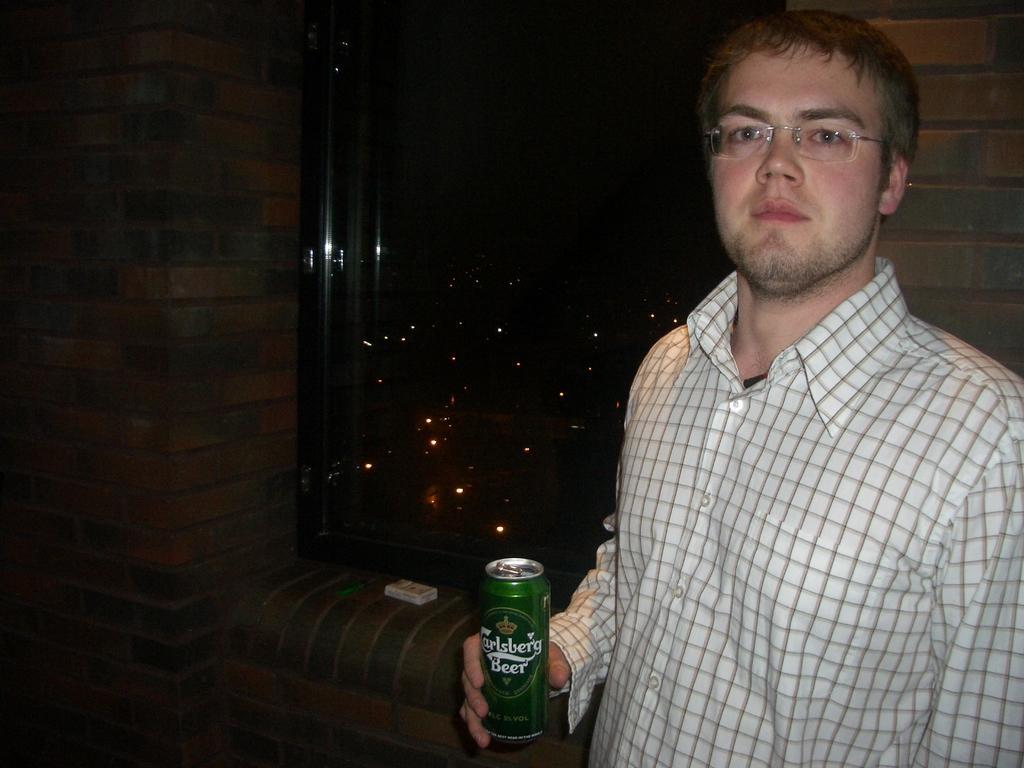Could you give a brief overview of what you see in this image? The person wearing a white shirt is holding a beer in his right hand there is a window behind him. 